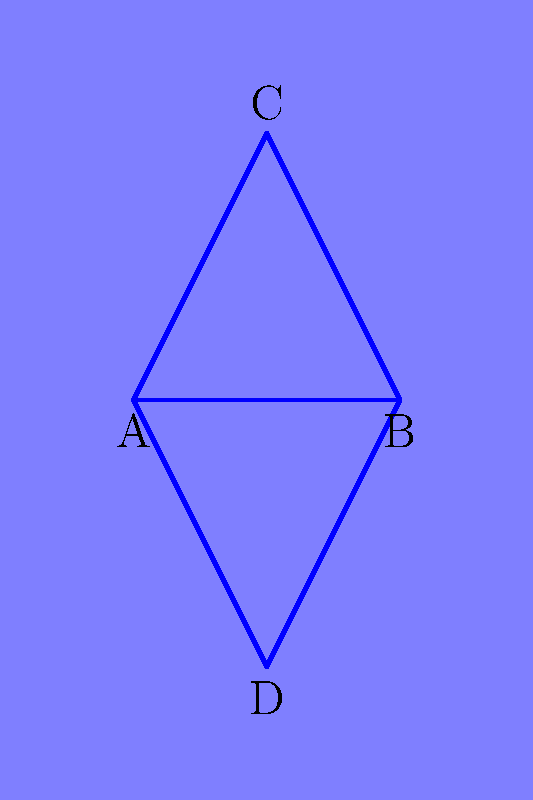In your water-based level design for an indie game using MonoGame, you have four islands (A, B, C, and D) that need to be connected by bridges. What is the minimum number of bridges required to ensure that a player can travel between any two islands, either directly or indirectly? To solve this problem, we can use the concept of a minimum spanning tree from graph theory. Here's a step-by-step explanation:

1. Treat each island as a node in a graph.
2. The bridges between islands are the edges of the graph.
3. We need to find the minimum number of edges that connect all nodes without creating cycles.
4. The minimum number of edges needed to connect $n$ nodes in a graph is always $n-1$.

In this case:
1. We have 4 islands (nodes).
2. Using the formula: minimum number of bridges = $n - 1$
3. $4 - 1 = 3$

Therefore, the minimum number of bridges needed is 3. This configuration ensures that all islands are connected, either directly or indirectly, with the least number of bridges possible.

Note: In the diagram, 5 bridges are shown for illustration purposes, but only 3 are necessary for the minimum configuration.
Answer: 3 bridges 